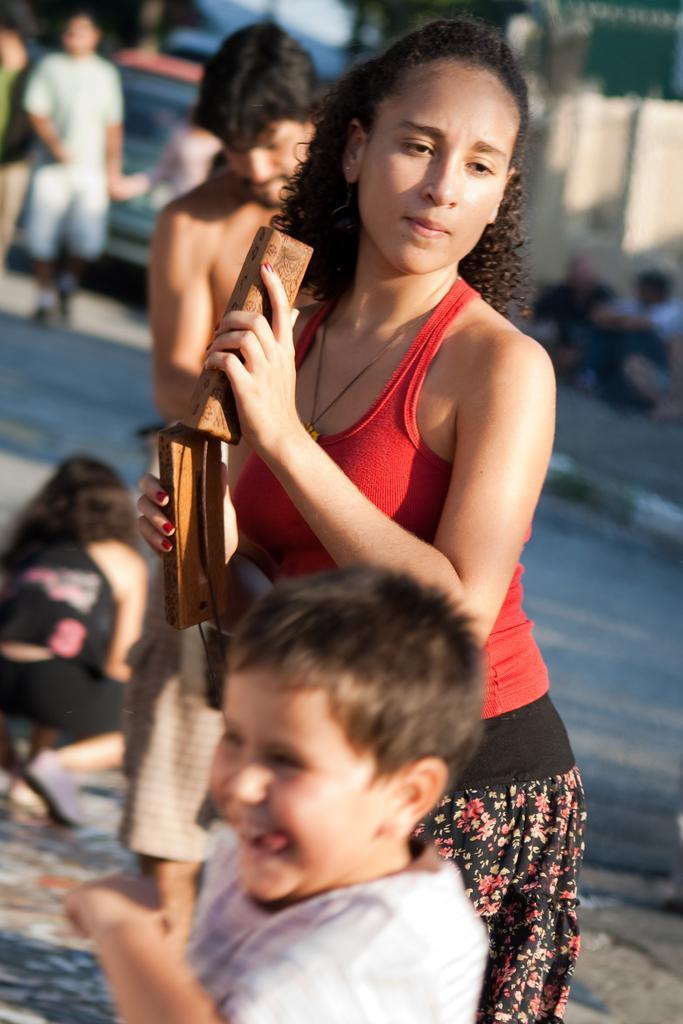In one or two sentences, can you explain what this image depicts? In this picture we can see a group of people on the ground, one woman is holding objects and in the background we can see a vehicle and some objects. 